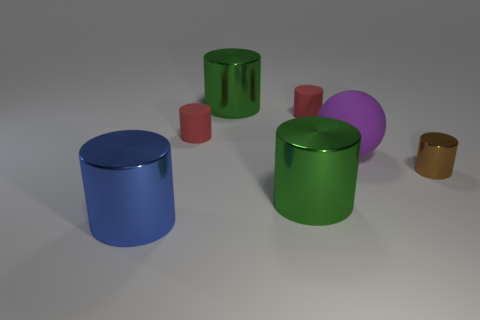Subtract all brown cylinders. How many cylinders are left? 5 Subtract 1 cylinders. How many cylinders are left? 5 Subtract all small brown metal cylinders. How many cylinders are left? 5 Subtract all red cylinders. Subtract all brown spheres. How many cylinders are left? 4 Add 1 big cyan shiny balls. How many objects exist? 8 Subtract all cylinders. How many objects are left? 1 Add 7 balls. How many balls are left? 8 Add 6 red matte objects. How many red matte objects exist? 8 Subtract 0 purple cubes. How many objects are left? 7 Subtract all big blue metal things. Subtract all blue metal cylinders. How many objects are left? 5 